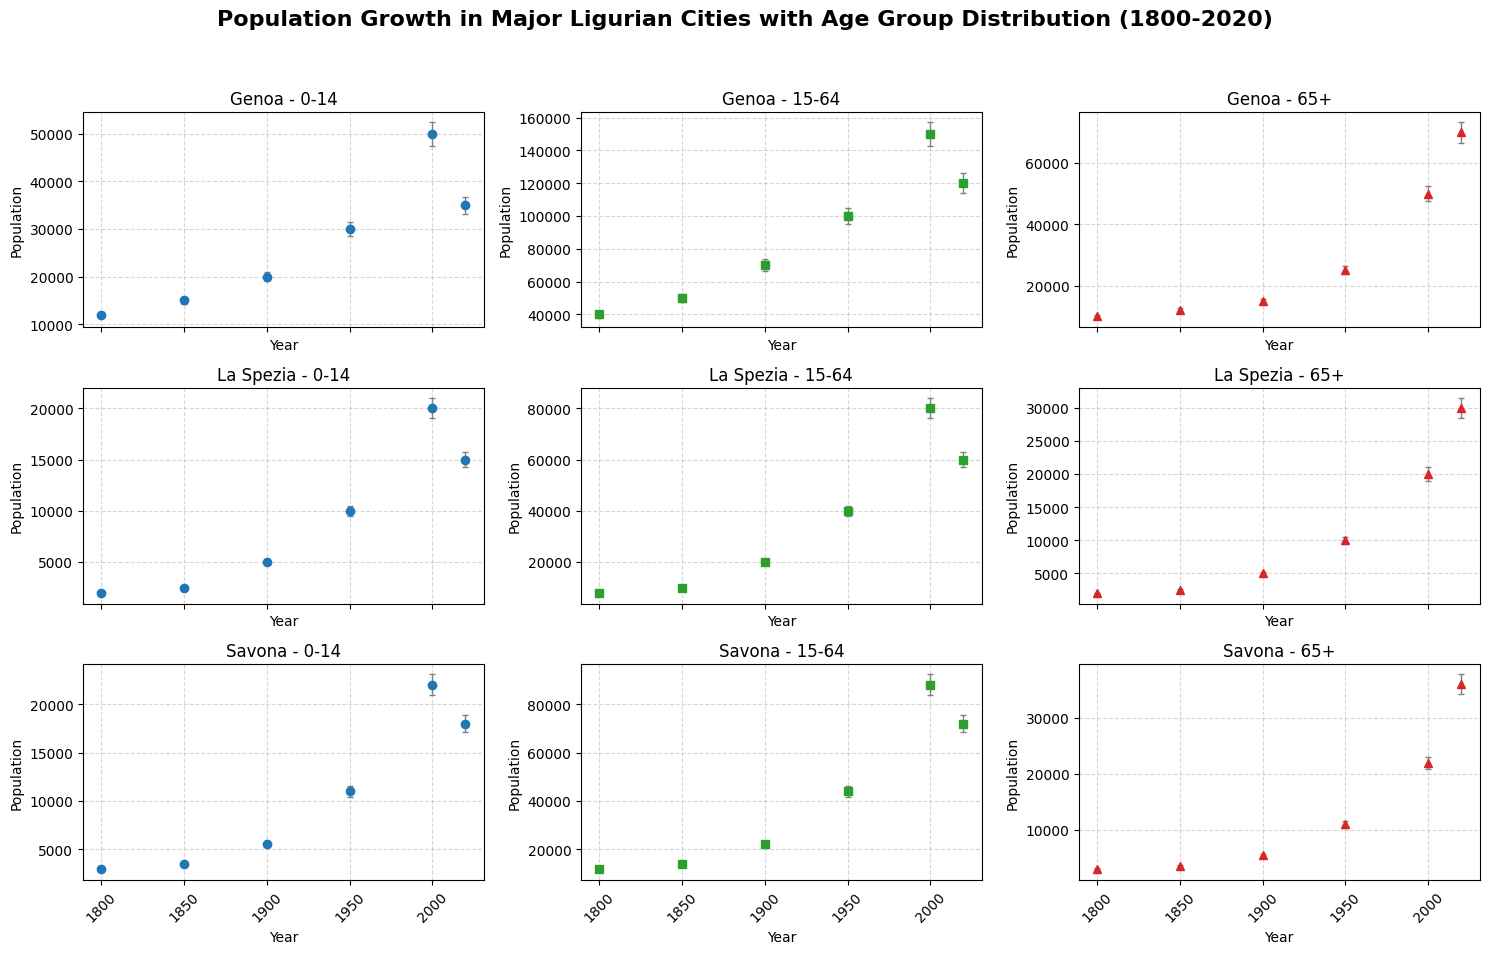What age group in Genoa had the highest population in 1950? Compare the population statistics for each age group in Genoa for the year 1950. The age group 15-64 had 100,000, which is the highest among the groups.
Answer: 15-64 Which city had the largest population in the 0-14 age group in the year 2000? Review the bar heights for the 0-14 age group for each city in 2000. Genoa had the largest population with 50,000.
Answer: Genoa Between 1800 and 2020, in which city did the 65+ age group see the largest increase in population? Calculate the difference in population for the 65+ age group between 2020 and 1800 for each city. In Genoa, the population increased from 10,000 in 1800 to 70,000 in 2020, which is the largest increase (60,000).
Answer: Genoa Was the error margin in the 15-64 age group population larger in Genoa or La Spezia in 2020? Compare the error margins in the 15-64 age group between Genoa and La Spezia in 2020. Genoa had an error margin of 6,000, while La Spezia had an error margin of 3,000.
Answer: Genoa How did the population of the 0-14 age group in Savona change from 1800 to 2020? Compare the population numbers of the 0-14 age group in Savona in 1800 and 2020. The population increased from 3,000 in 1800 to 18,000 in 2020.
Answer: Increased In the year 1900, which age group had the lowest population in La Spezia? Check the population figures for each age group in La Spezia for the year 1900. The 65+ age group had the lowest population with 5,000.
Answer: 65+ Comparing the 2000 data, which age group had the highest error margin in Savona? Look at the error margins for each age group in Savona for the year 2000. The age group 15-64 had the highest error margin, with 4,400.
Answer: 15-64 What was the total population of Genoa in 1850? Add together the populations of each age group in Genoa for the year 1850 (15,000 + 50,000 + 12,000). The total is 77,000.
Answer: 77,000 